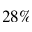Convert formula to latex. <formula><loc_0><loc_0><loc_500><loc_500>2 8 \%</formula> 